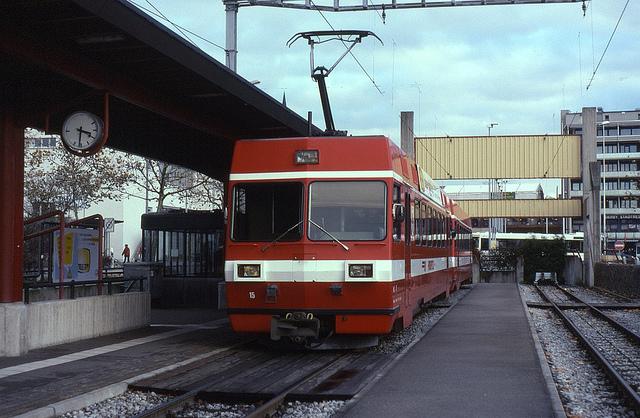What time is the clock showing?
Quick response, please. 3:30. Is this a passenger train?
Keep it brief. Yes. Is this a steam or electric train?
Give a very brief answer. Electric. 